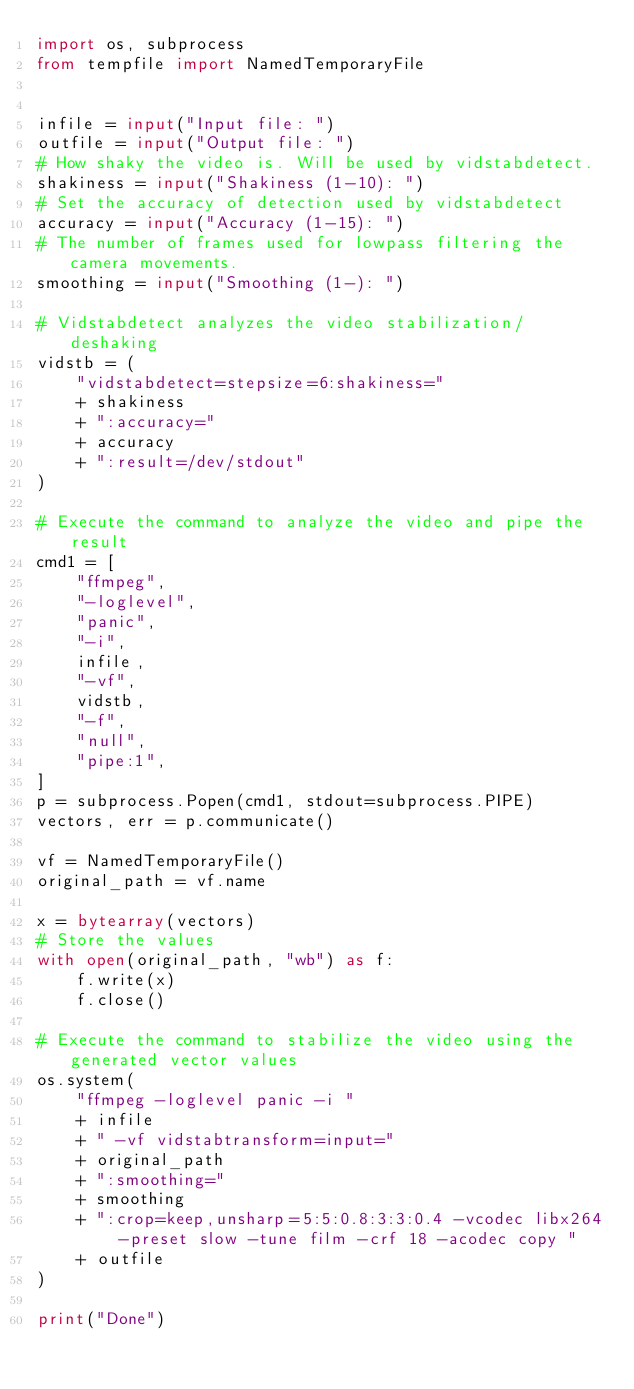Convert code to text. <code><loc_0><loc_0><loc_500><loc_500><_Python_>import os, subprocess
from tempfile import NamedTemporaryFile


infile = input("Input file: ")
outfile = input("Output file: ")
# How shaky the video is. Will be used by vidstabdetect.
shakiness = input("Shakiness (1-10): ")
# Set the accuracy of detection used by vidstabdetect
accuracy = input("Accuracy (1-15): ")
# The number of frames used for lowpass filtering the camera movements.
smoothing = input("Smoothing (1-): ")

# Vidstabdetect analyzes the video stabilization/deshaking
vidstb = (
    "vidstabdetect=stepsize=6:shakiness="
    + shakiness
    + ":accuracy="
    + accuracy
    + ":result=/dev/stdout"
)

# Execute the command to analyze the video and pipe the result
cmd1 = [
    "ffmpeg",
    "-loglevel",
    "panic",
    "-i",
    infile,
    "-vf",
    vidstb,
    "-f",
    "null",
    "pipe:1",
]
p = subprocess.Popen(cmd1, stdout=subprocess.PIPE)
vectors, err = p.communicate()

vf = NamedTemporaryFile()
original_path = vf.name

x = bytearray(vectors)
# Store the values
with open(original_path, "wb") as f:
    f.write(x)
    f.close()

# Execute the command to stabilize the video using the generated vector values
os.system(
    "ffmpeg -loglevel panic -i "
    + infile
    + " -vf vidstabtransform=input="
    + original_path
    + ":smoothing="
    + smoothing
    + ":crop=keep,unsharp=5:5:0.8:3:3:0.4 -vcodec libx264 -preset slow -tune film -crf 18 -acodec copy "
    + outfile
)

print("Done")
</code> 